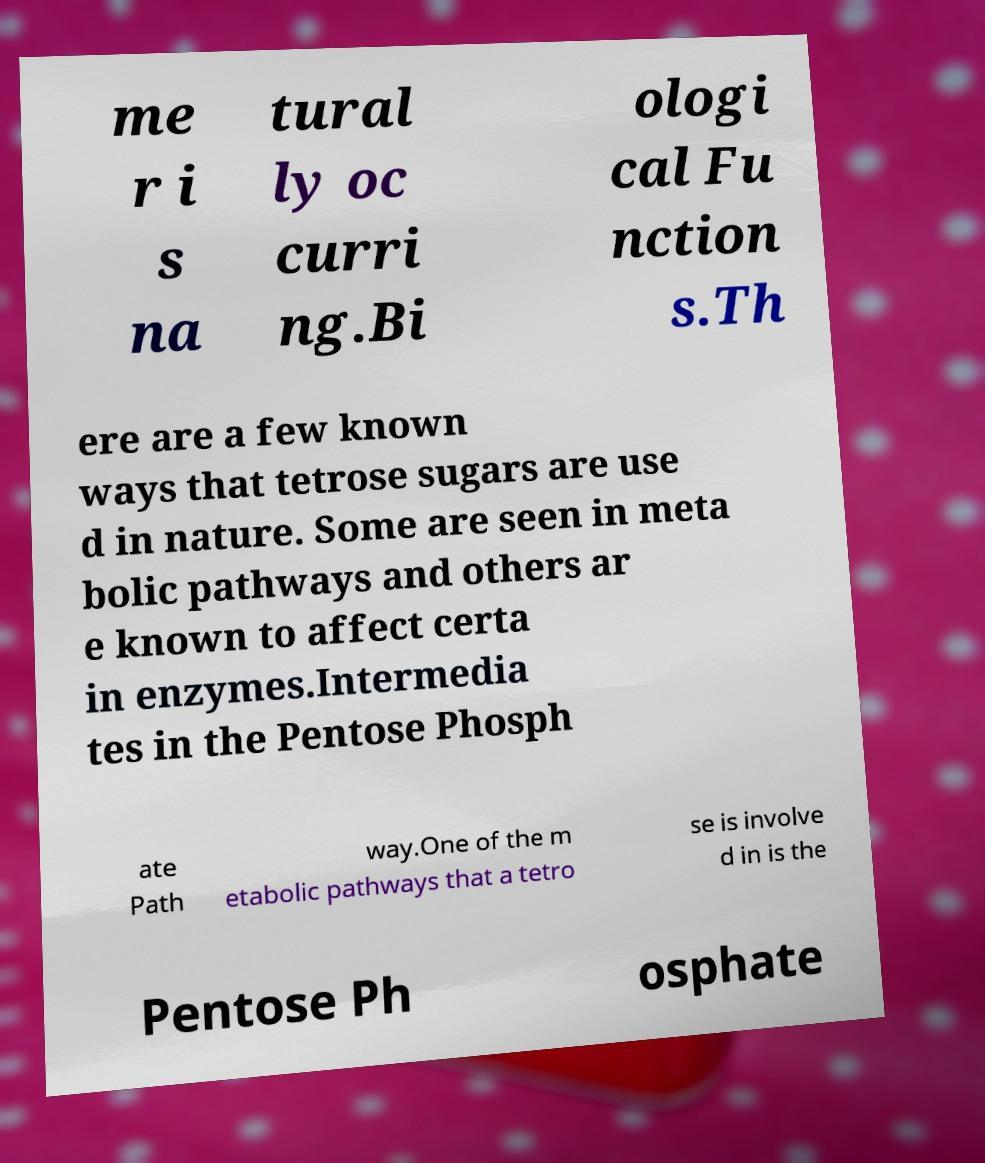Could you assist in decoding the text presented in this image and type it out clearly? me r i s na tural ly oc curri ng.Bi ologi cal Fu nction s.Th ere are a few known ways that tetrose sugars are use d in nature. Some are seen in meta bolic pathways and others ar e known to affect certa in enzymes.Intermedia tes in the Pentose Phosph ate Path way.One of the m etabolic pathways that a tetro se is involve d in is the Pentose Ph osphate 